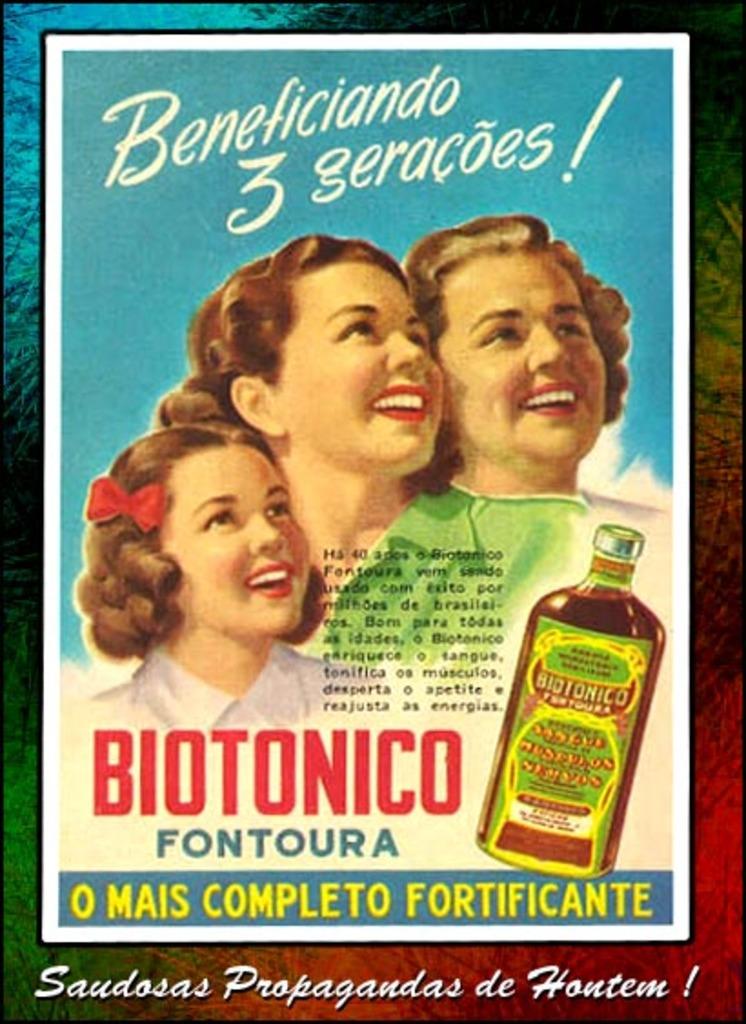What number is written in white script at the top?
Offer a very short reply. 3. 